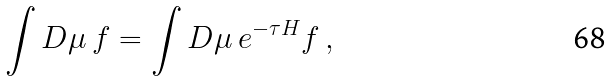<formula> <loc_0><loc_0><loc_500><loc_500>\int D \mu \, f = \int D \mu \, e ^ { - \tau H } f \, ,</formula> 